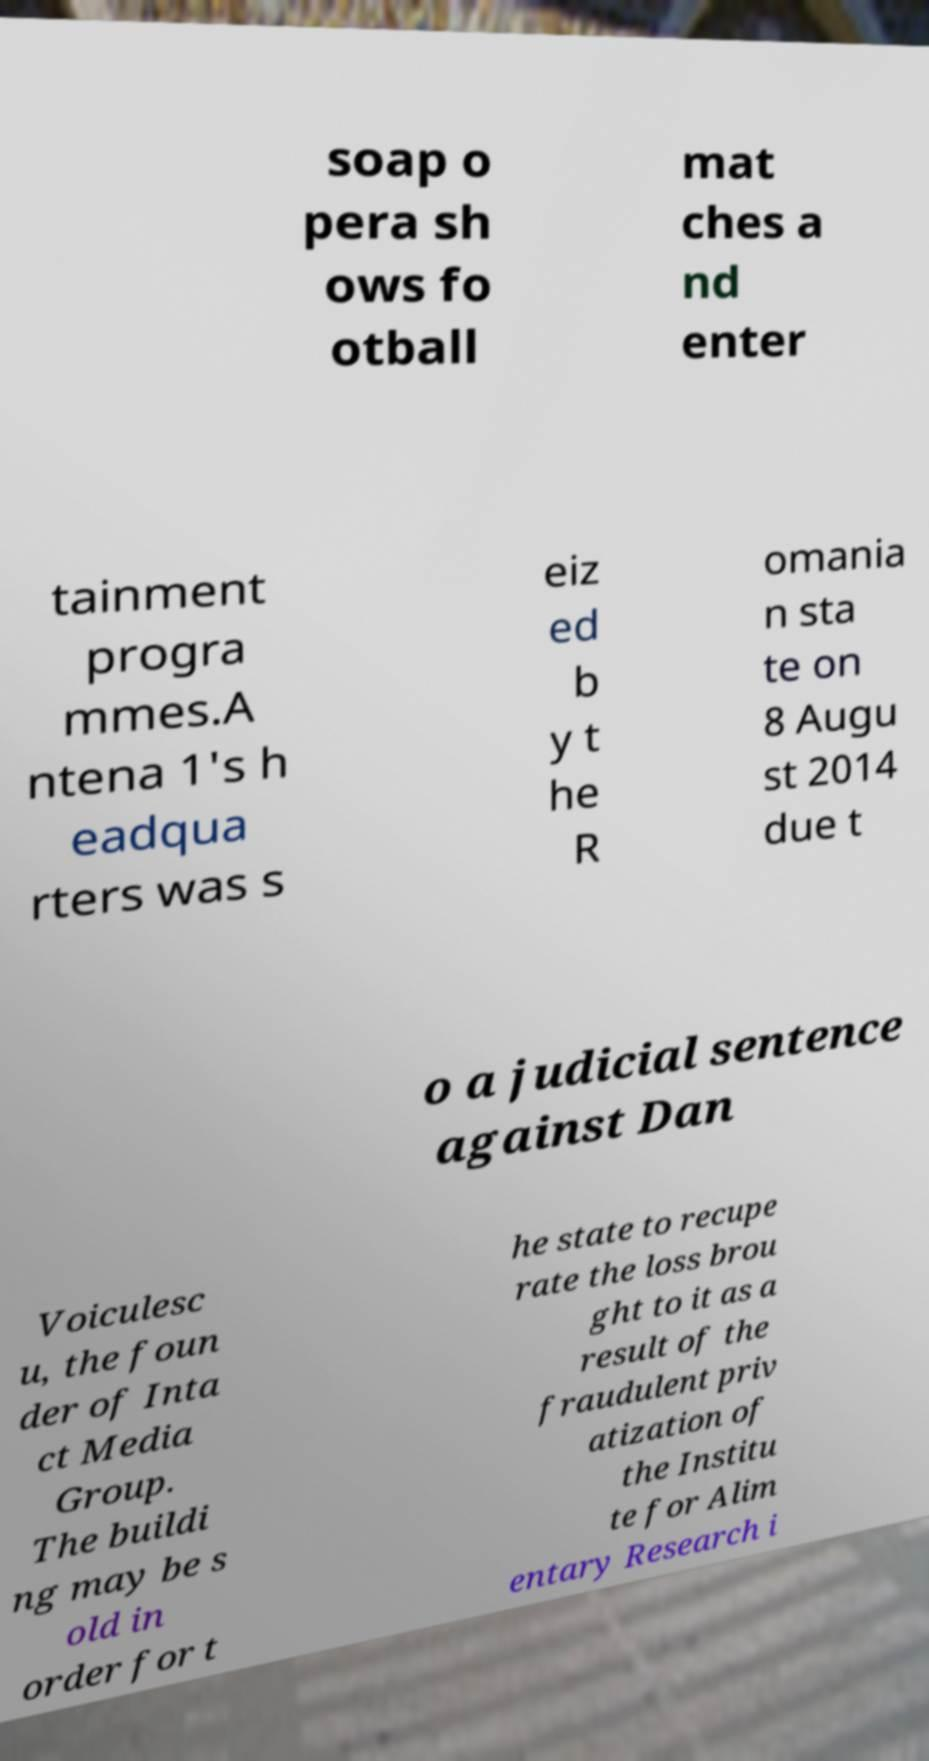For documentation purposes, I need the text within this image transcribed. Could you provide that? soap o pera sh ows fo otball mat ches a nd enter tainment progra mmes.A ntena 1's h eadqua rters was s eiz ed b y t he R omania n sta te on 8 Augu st 2014 due t o a judicial sentence against Dan Voiculesc u, the foun der of Inta ct Media Group. The buildi ng may be s old in order for t he state to recupe rate the loss brou ght to it as a result of the fraudulent priv atization of the Institu te for Alim entary Research i 